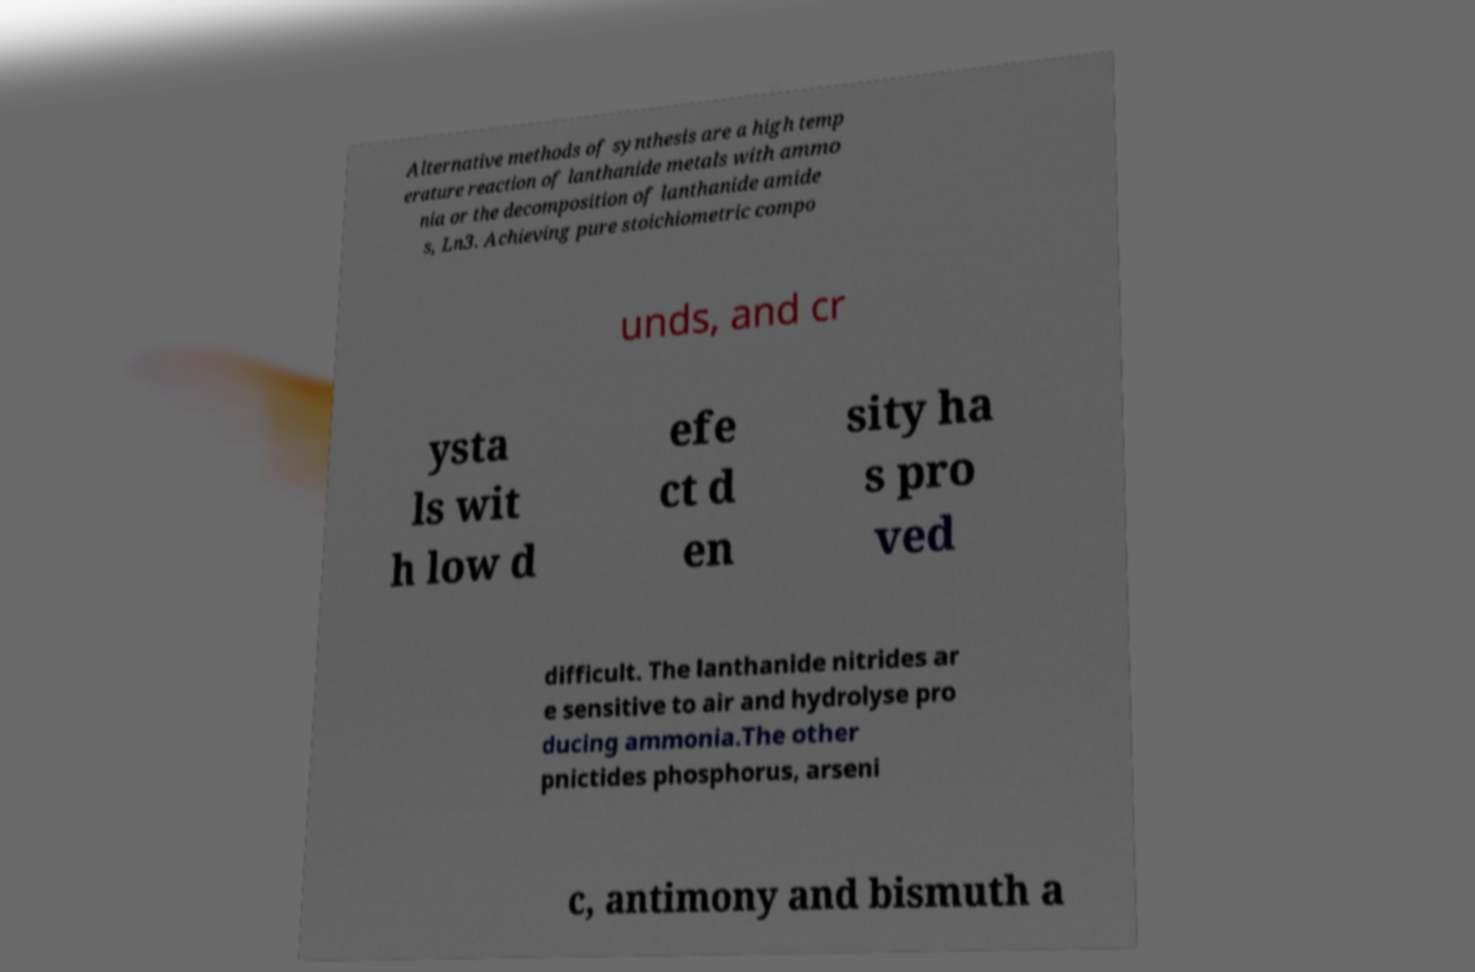Can you accurately transcribe the text from the provided image for me? Alternative methods of synthesis are a high temp erature reaction of lanthanide metals with ammo nia or the decomposition of lanthanide amide s, Ln3. Achieving pure stoichiometric compo unds, and cr ysta ls wit h low d efe ct d en sity ha s pro ved difficult. The lanthanide nitrides ar e sensitive to air and hydrolyse pro ducing ammonia.The other pnictides phosphorus, arseni c, antimony and bismuth a 